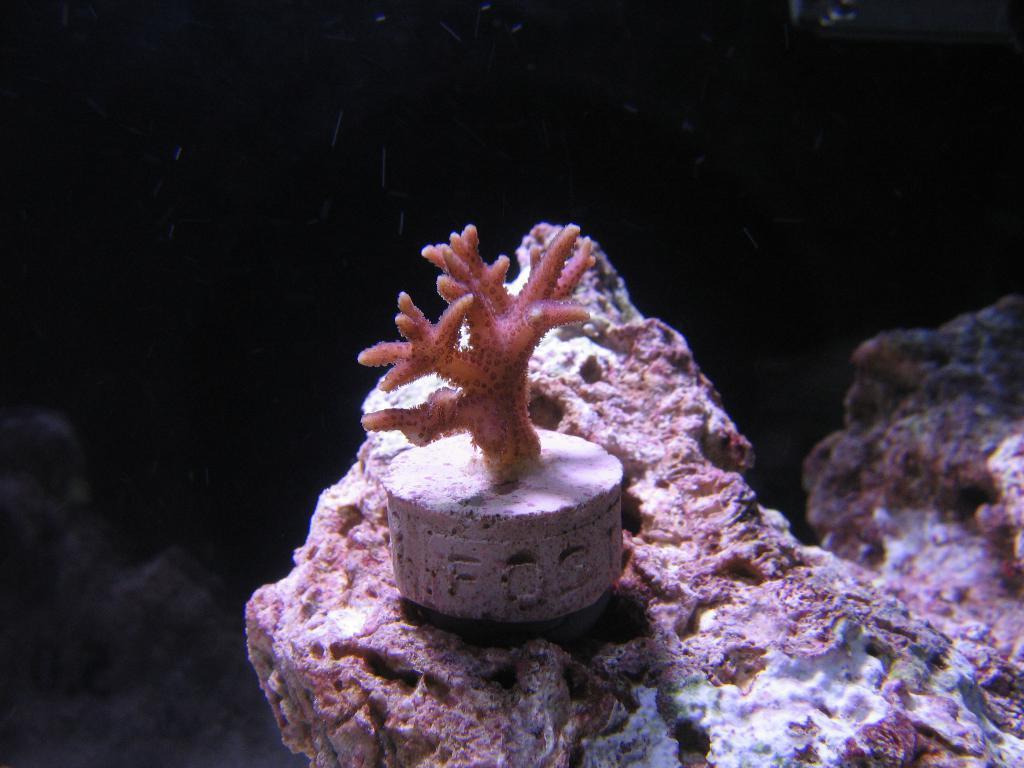Please provide a concise description of this image. In the middle of the image there is a marine species. In this image the background is dark. At the bottom of the image there is a rock. 